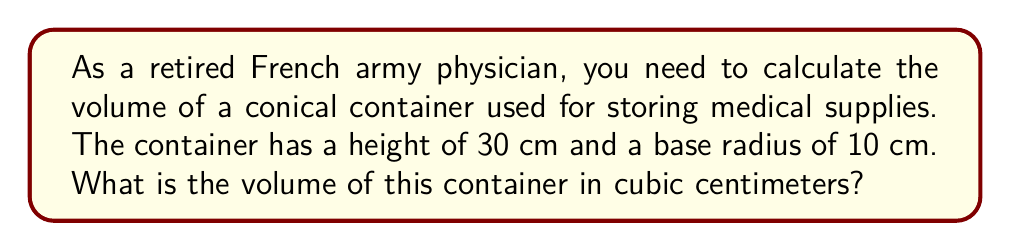Show me your answer to this math problem. To solve this problem, we'll follow these steps:

1. Recall the formula for the volume of a cone:
   $$V = \frac{1}{3}\pi r^2 h$$
   where $V$ is the volume, $r$ is the radius of the base, and $h$ is the height of the cone.

2. Substitute the given values:
   $r = 10$ cm
   $h = 30$ cm

3. Apply the formula:
   $$V = \frac{1}{3}\pi (10\text{ cm})^2 (30\text{ cm})$$

4. Simplify:
   $$V = \frac{1}{3}\pi (100\text{ cm}^2) (30\text{ cm})$$
   $$V = \frac{1}{3}\pi (3000\text{ cm}^3)$$
   $$V = 1000\pi\text{ cm}^3$$

5. Calculate the final result:
   $$V \approx 3141.59\text{ cm}^3$$

[asy]
import geometry;

size(200);
real r = 3;
real h = 9;

path cone = (0,0)--(r,0)--(-r,0)--cycle;
path side = (0,h)--(r,0)--(-r,0)--cycle;

draw(cone);
draw(side);
draw((0,h)--(0,0), dashed);

label("r", (r/2,-0.5));
label("h", (-0.5,h/2));
[/asy]
Answer: $3141.59\text{ cm}^3$ 